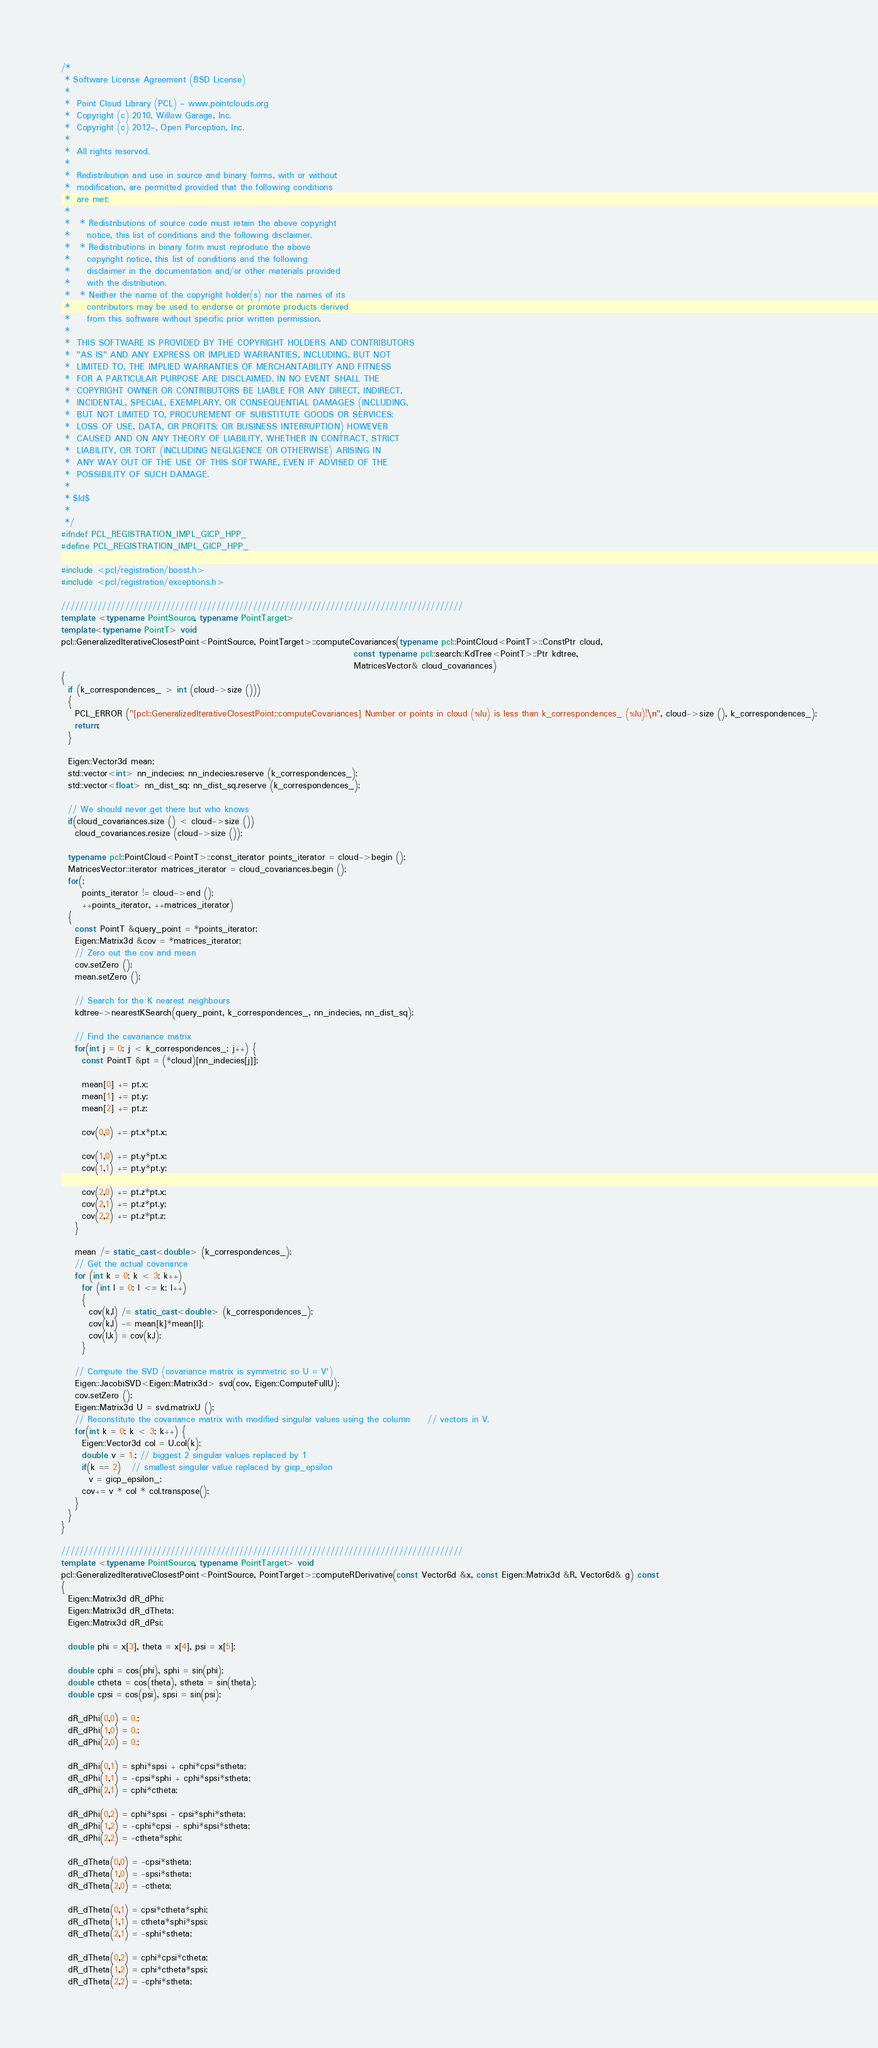<code> <loc_0><loc_0><loc_500><loc_500><_C++_>/*
 * Software License Agreement (BSD License)
 *
 *  Point Cloud Library (PCL) - www.pointclouds.org
 *  Copyright (c) 2010, Willow Garage, Inc.
 *  Copyright (c) 2012-, Open Perception, Inc.
 *
 *  All rights reserved.
 *
 *  Redistribution and use in source and binary forms, with or without
 *  modification, are permitted provided that the following conditions
 *  are met:
 *
 *   * Redistributions of source code must retain the above copyright
 *     notice, this list of conditions and the following disclaimer.
 *   * Redistributions in binary form must reproduce the above
 *     copyright notice, this list of conditions and the following
 *     disclaimer in the documentation and/or other materials provided
 *     with the distribution.
 *   * Neither the name of the copyright holder(s) nor the names of its
 *     contributors may be used to endorse or promote products derived
 *     from this software without specific prior written permission.
 *
 *  THIS SOFTWARE IS PROVIDED BY THE COPYRIGHT HOLDERS AND CONTRIBUTORS
 *  "AS IS" AND ANY EXPRESS OR IMPLIED WARRANTIES, INCLUDING, BUT NOT
 *  LIMITED TO, THE IMPLIED WARRANTIES OF MERCHANTABILITY AND FITNESS
 *  FOR A PARTICULAR PURPOSE ARE DISCLAIMED. IN NO EVENT SHALL THE
 *  COPYRIGHT OWNER OR CONTRIBUTORS BE LIABLE FOR ANY DIRECT, INDIRECT,
 *  INCIDENTAL, SPECIAL, EXEMPLARY, OR CONSEQUENTIAL DAMAGES (INCLUDING,
 *  BUT NOT LIMITED TO, PROCUREMENT OF SUBSTITUTE GOODS OR SERVICES;
 *  LOSS OF USE, DATA, OR PROFITS; OR BUSINESS INTERRUPTION) HOWEVER
 *  CAUSED AND ON ANY THEORY OF LIABILITY, WHETHER IN CONTRACT, STRICT
 *  LIABILITY, OR TORT (INCLUDING NEGLIGENCE OR OTHERWISE) ARISING IN
 *  ANY WAY OUT OF THE USE OF THIS SOFTWARE, EVEN IF ADVISED OF THE
 *  POSSIBILITY OF SUCH DAMAGE.
 *
 * $Id$
 *
 */
#ifndef PCL_REGISTRATION_IMPL_GICP_HPP_
#define PCL_REGISTRATION_IMPL_GICP_HPP_

#include <pcl/registration/boost.h>
#include <pcl/registration/exceptions.h>

////////////////////////////////////////////////////////////////////////////////////////
template <typename PointSource, typename PointTarget>
template<typename PointT> void
pcl::GeneralizedIterativeClosestPoint<PointSource, PointTarget>::computeCovariances(typename pcl::PointCloud<PointT>::ConstPtr cloud,
                                                                                    const typename pcl::search::KdTree<PointT>::Ptr kdtree,
                                                                                    MatricesVector& cloud_covariances)
{
  if (k_correspondences_ > int (cloud->size ()))
  {
    PCL_ERROR ("[pcl::GeneralizedIterativeClosestPoint::computeCovariances] Number or points in cloud (%lu) is less than k_correspondences_ (%lu)!\n", cloud->size (), k_correspondences_);
    return;
  }

  Eigen::Vector3d mean;
  std::vector<int> nn_indecies; nn_indecies.reserve (k_correspondences_);
  std::vector<float> nn_dist_sq; nn_dist_sq.reserve (k_correspondences_);

  // We should never get there but who knows
  if(cloud_covariances.size () < cloud->size ())
    cloud_covariances.resize (cloud->size ());

  typename pcl::PointCloud<PointT>::const_iterator points_iterator = cloud->begin ();
  MatricesVector::iterator matrices_iterator = cloud_covariances.begin ();
  for(;
      points_iterator != cloud->end ();
      ++points_iterator, ++matrices_iterator)
  {
    const PointT &query_point = *points_iterator;
    Eigen::Matrix3d &cov = *matrices_iterator;
    // Zero out the cov and mean
    cov.setZero ();
    mean.setZero ();

    // Search for the K nearest neighbours
    kdtree->nearestKSearch(query_point, k_correspondences_, nn_indecies, nn_dist_sq);

    // Find the covariance matrix
    for(int j = 0; j < k_correspondences_; j++) {
      const PointT &pt = (*cloud)[nn_indecies[j]];

      mean[0] += pt.x;
      mean[1] += pt.y;
      mean[2] += pt.z;

      cov(0,0) += pt.x*pt.x;

      cov(1,0) += pt.y*pt.x;
      cov(1,1) += pt.y*pt.y;

      cov(2,0) += pt.z*pt.x;
      cov(2,1) += pt.z*pt.y;
      cov(2,2) += pt.z*pt.z;
    }

    mean /= static_cast<double> (k_correspondences_);
    // Get the actual covariance
    for (int k = 0; k < 3; k++)
      for (int l = 0; l <= k; l++)
      {
        cov(k,l) /= static_cast<double> (k_correspondences_);
        cov(k,l) -= mean[k]*mean[l];
        cov(l,k) = cov(k,l);
      }

    // Compute the SVD (covariance matrix is symmetric so U = V')
    Eigen::JacobiSVD<Eigen::Matrix3d> svd(cov, Eigen::ComputeFullU);
    cov.setZero ();
    Eigen::Matrix3d U = svd.matrixU ();
    // Reconstitute the covariance matrix with modified singular values using the column     // vectors in V.
    for(int k = 0; k < 3; k++) {
      Eigen::Vector3d col = U.col(k);
      double v = 1.; // biggest 2 singular values replaced by 1
      if(k == 2)   // smallest singular value replaced by gicp_epsilon
        v = gicp_epsilon_;
      cov+= v * col * col.transpose();
    }
  }
}

////////////////////////////////////////////////////////////////////////////////////////
template <typename PointSource, typename PointTarget> void
pcl::GeneralizedIterativeClosestPoint<PointSource, PointTarget>::computeRDerivative(const Vector6d &x, const Eigen::Matrix3d &R, Vector6d& g) const
{
  Eigen::Matrix3d dR_dPhi;
  Eigen::Matrix3d dR_dTheta;
  Eigen::Matrix3d dR_dPsi;

  double phi = x[3], theta = x[4], psi = x[5];

  double cphi = cos(phi), sphi = sin(phi);
  double ctheta = cos(theta), stheta = sin(theta);
  double cpsi = cos(psi), spsi = sin(psi);

  dR_dPhi(0,0) = 0.;
  dR_dPhi(1,0) = 0.;
  dR_dPhi(2,0) = 0.;

  dR_dPhi(0,1) = sphi*spsi + cphi*cpsi*stheta;
  dR_dPhi(1,1) = -cpsi*sphi + cphi*spsi*stheta;
  dR_dPhi(2,1) = cphi*ctheta;

  dR_dPhi(0,2) = cphi*spsi - cpsi*sphi*stheta;
  dR_dPhi(1,2) = -cphi*cpsi - sphi*spsi*stheta;
  dR_dPhi(2,2) = -ctheta*sphi;

  dR_dTheta(0,0) = -cpsi*stheta;
  dR_dTheta(1,0) = -spsi*stheta;
  dR_dTheta(2,0) = -ctheta;

  dR_dTheta(0,1) = cpsi*ctheta*sphi;
  dR_dTheta(1,1) = ctheta*sphi*spsi;
  dR_dTheta(2,1) = -sphi*stheta;

  dR_dTheta(0,2) = cphi*cpsi*ctheta;
  dR_dTheta(1,2) = cphi*ctheta*spsi;
  dR_dTheta(2,2) = -cphi*stheta;
</code> 